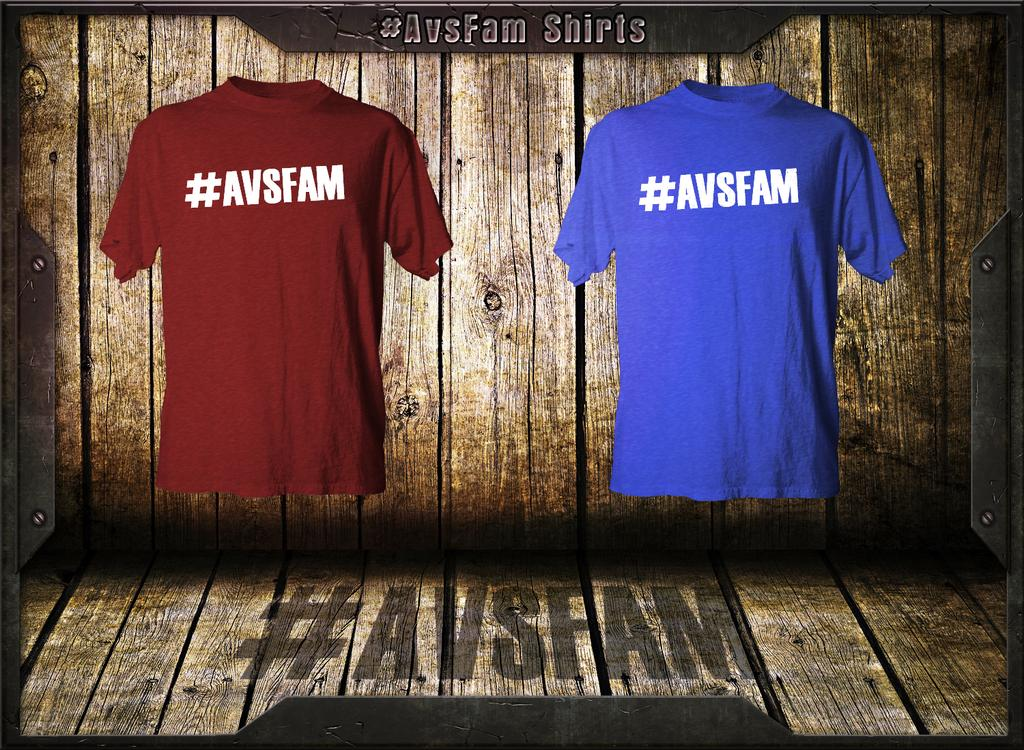<image>
Present a compact description of the photo's key features. the letters AVSFAM on a blue shirt on a wall 